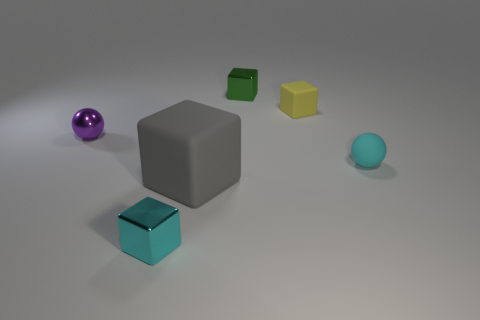Subtract all cyan cubes. How many cubes are left? 3 Subtract all tiny matte blocks. How many blocks are left? 3 Subtract all blue cubes. Subtract all yellow cylinders. How many cubes are left? 4 Add 1 large yellow rubber things. How many objects exist? 7 Subtract all blocks. How many objects are left? 2 Add 6 tiny green cubes. How many tiny green cubes are left? 7 Add 1 big cubes. How many big cubes exist? 2 Subtract 0 purple cylinders. How many objects are left? 6 Subtract all tiny yellow shiny balls. Subtract all small purple shiny balls. How many objects are left? 5 